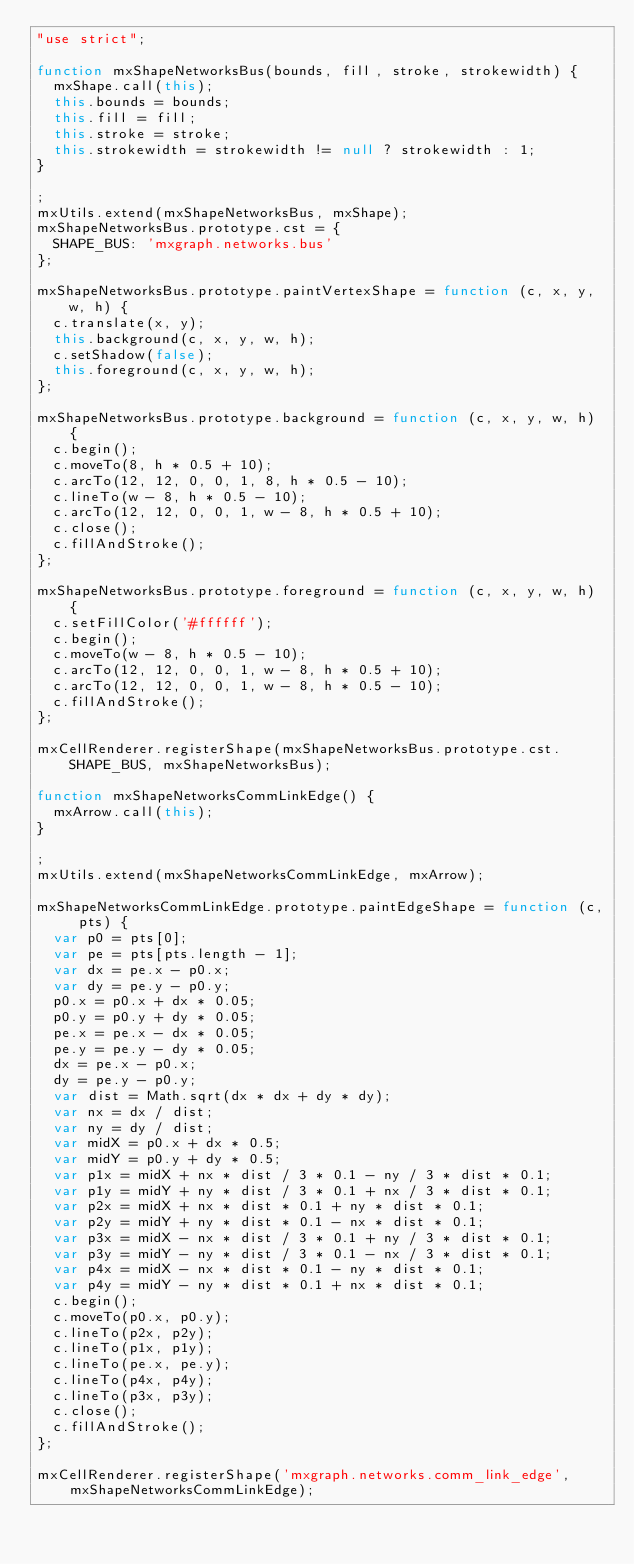<code> <loc_0><loc_0><loc_500><loc_500><_JavaScript_>"use strict";

function mxShapeNetworksBus(bounds, fill, stroke, strokewidth) {
  mxShape.call(this);
  this.bounds = bounds;
  this.fill = fill;
  this.stroke = stroke;
  this.strokewidth = strokewidth != null ? strokewidth : 1;
}

;
mxUtils.extend(mxShapeNetworksBus, mxShape);
mxShapeNetworksBus.prototype.cst = {
  SHAPE_BUS: 'mxgraph.networks.bus'
};

mxShapeNetworksBus.prototype.paintVertexShape = function (c, x, y, w, h) {
  c.translate(x, y);
  this.background(c, x, y, w, h);
  c.setShadow(false);
  this.foreground(c, x, y, w, h);
};

mxShapeNetworksBus.prototype.background = function (c, x, y, w, h) {
  c.begin();
  c.moveTo(8, h * 0.5 + 10);
  c.arcTo(12, 12, 0, 0, 1, 8, h * 0.5 - 10);
  c.lineTo(w - 8, h * 0.5 - 10);
  c.arcTo(12, 12, 0, 0, 1, w - 8, h * 0.5 + 10);
  c.close();
  c.fillAndStroke();
};

mxShapeNetworksBus.prototype.foreground = function (c, x, y, w, h) {
  c.setFillColor('#ffffff');
  c.begin();
  c.moveTo(w - 8, h * 0.5 - 10);
  c.arcTo(12, 12, 0, 0, 1, w - 8, h * 0.5 + 10);
  c.arcTo(12, 12, 0, 0, 1, w - 8, h * 0.5 - 10);
  c.fillAndStroke();
};

mxCellRenderer.registerShape(mxShapeNetworksBus.prototype.cst.SHAPE_BUS, mxShapeNetworksBus);

function mxShapeNetworksCommLinkEdge() {
  mxArrow.call(this);
}

;
mxUtils.extend(mxShapeNetworksCommLinkEdge, mxArrow);

mxShapeNetworksCommLinkEdge.prototype.paintEdgeShape = function (c, pts) {
  var p0 = pts[0];
  var pe = pts[pts.length - 1];
  var dx = pe.x - p0.x;
  var dy = pe.y - p0.y;
  p0.x = p0.x + dx * 0.05;
  p0.y = p0.y + dy * 0.05;
  pe.x = pe.x - dx * 0.05;
  pe.y = pe.y - dy * 0.05;
  dx = pe.x - p0.x;
  dy = pe.y - p0.y;
  var dist = Math.sqrt(dx * dx + dy * dy);
  var nx = dx / dist;
  var ny = dy / dist;
  var midX = p0.x + dx * 0.5;
  var midY = p0.y + dy * 0.5;
  var p1x = midX + nx * dist / 3 * 0.1 - ny / 3 * dist * 0.1;
  var p1y = midY + ny * dist / 3 * 0.1 + nx / 3 * dist * 0.1;
  var p2x = midX + nx * dist * 0.1 + ny * dist * 0.1;
  var p2y = midY + ny * dist * 0.1 - nx * dist * 0.1;
  var p3x = midX - nx * dist / 3 * 0.1 + ny / 3 * dist * 0.1;
  var p3y = midY - ny * dist / 3 * 0.1 - nx / 3 * dist * 0.1;
  var p4x = midX - nx * dist * 0.1 - ny * dist * 0.1;
  var p4y = midY - ny * dist * 0.1 + nx * dist * 0.1;
  c.begin();
  c.moveTo(p0.x, p0.y);
  c.lineTo(p2x, p2y);
  c.lineTo(p1x, p1y);
  c.lineTo(pe.x, pe.y);
  c.lineTo(p4x, p4y);
  c.lineTo(p3x, p3y);
  c.close();
  c.fillAndStroke();
};

mxCellRenderer.registerShape('mxgraph.networks.comm_link_edge', mxShapeNetworksCommLinkEdge);
</code> 